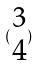<formula> <loc_0><loc_0><loc_500><loc_500>( \begin{matrix} 3 \\ 4 \end{matrix} )</formula> 